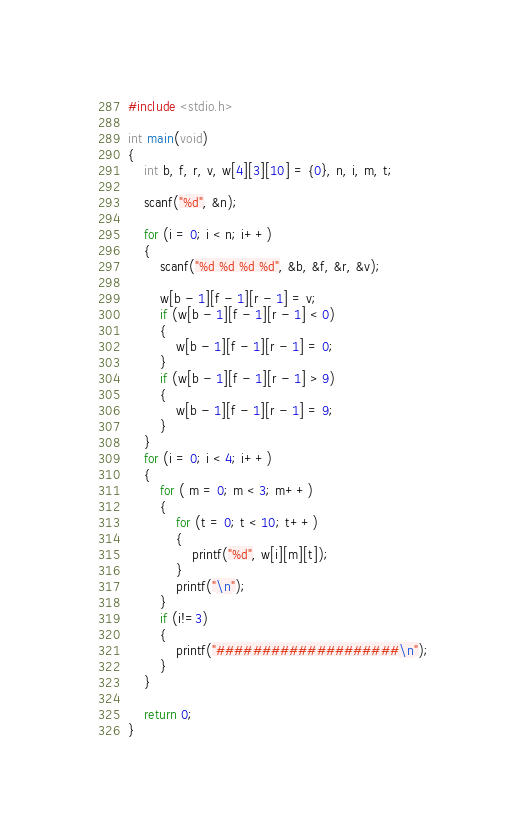Convert code to text. <code><loc_0><loc_0><loc_500><loc_500><_C_>#include <stdio.h>

int main(void)
{
	int b, f, r, v, w[4][3][10] = {0}, n, i, m, t;

	scanf("%d", &n);

	for (i = 0; i < n; i++)
	{
		scanf("%d %d %d %d", &b, &f, &r, &v);

		w[b - 1][f - 1][r - 1] = v;
		if (w[b - 1][f - 1][r - 1] < 0)
		{
			w[b - 1][f - 1][r - 1] = 0;
		}
		if (w[b - 1][f - 1][r - 1] > 9)
		{
			w[b - 1][f - 1][r - 1] = 9;
		}
	}
	for (i = 0; i < 4; i++)
	{
		for ( m = 0; m < 3; m++)
		{
			for (t = 0; t < 10; t++)
			{
				printf("%d", w[i][m][t]);
			}
			printf("\n");
		}
		if (i!=3)
		{
			printf("####################\n");
		}
	}
	
	return 0;
}
</code> 